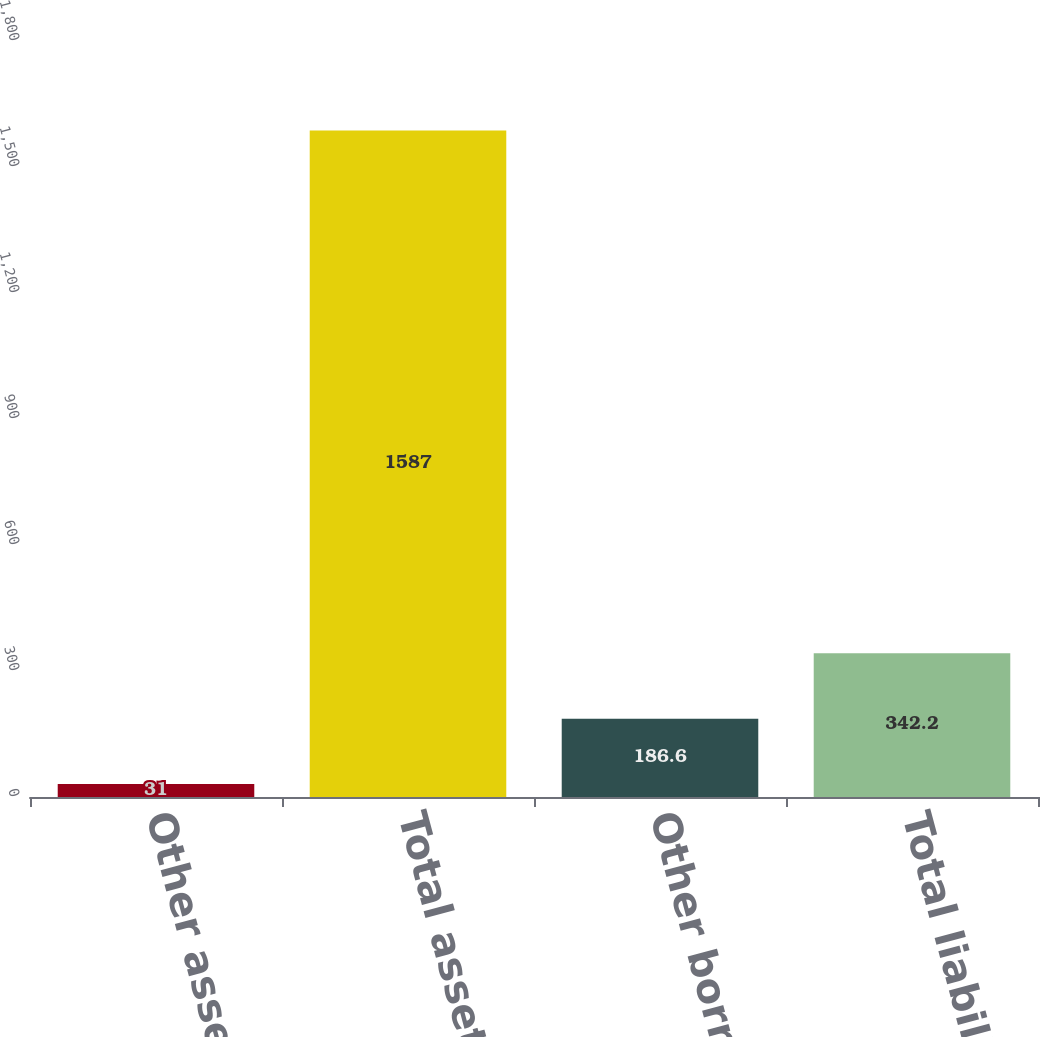Convert chart. <chart><loc_0><loc_0><loc_500><loc_500><bar_chart><fcel>Other assets<fcel>Total assets<fcel>Other borrowed funds<fcel>Total liabilities<nl><fcel>31<fcel>1587<fcel>186.6<fcel>342.2<nl></chart> 